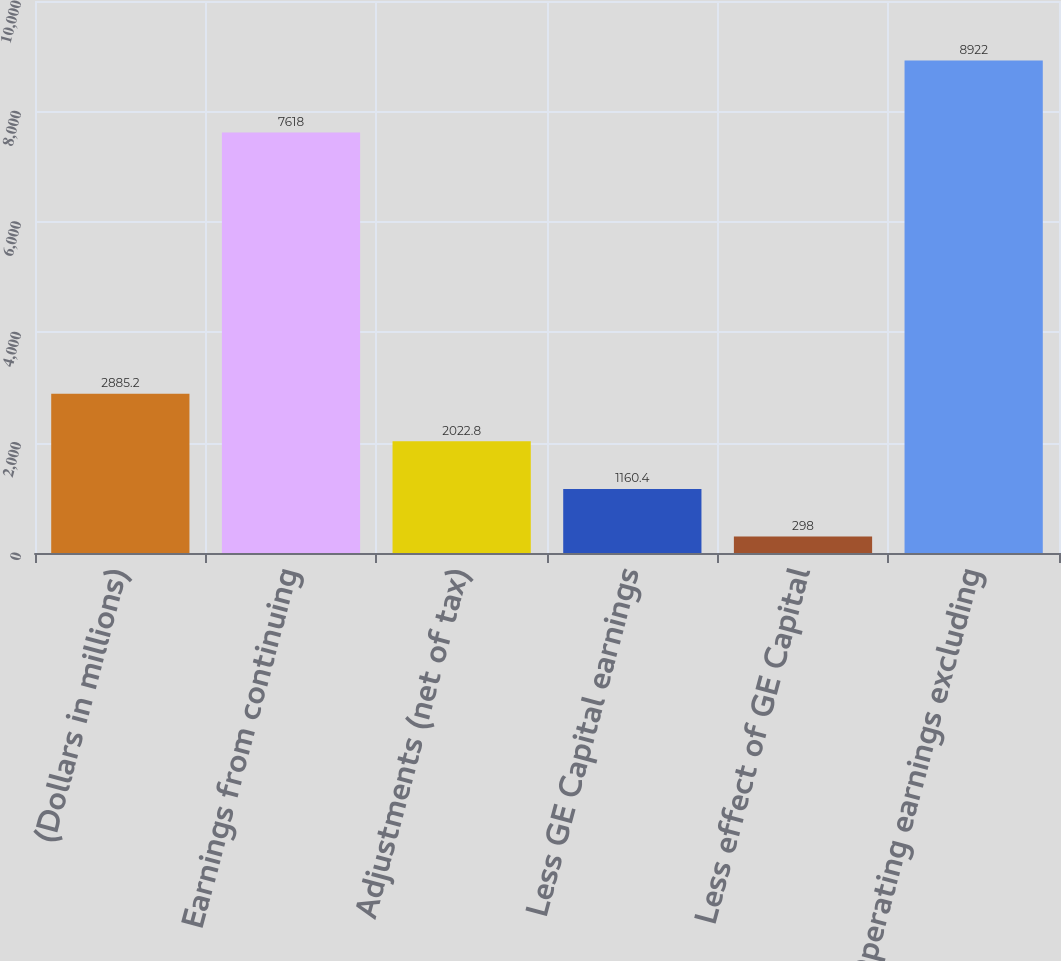Convert chart. <chart><loc_0><loc_0><loc_500><loc_500><bar_chart><fcel>(Dollars in millions)<fcel>Earnings from continuing<fcel>Adjustments (net of tax)<fcel>Less GE Capital earnings<fcel>Less effect of GE Capital<fcel>Operating earnings excluding<nl><fcel>2885.2<fcel>7618<fcel>2022.8<fcel>1160.4<fcel>298<fcel>8922<nl></chart> 